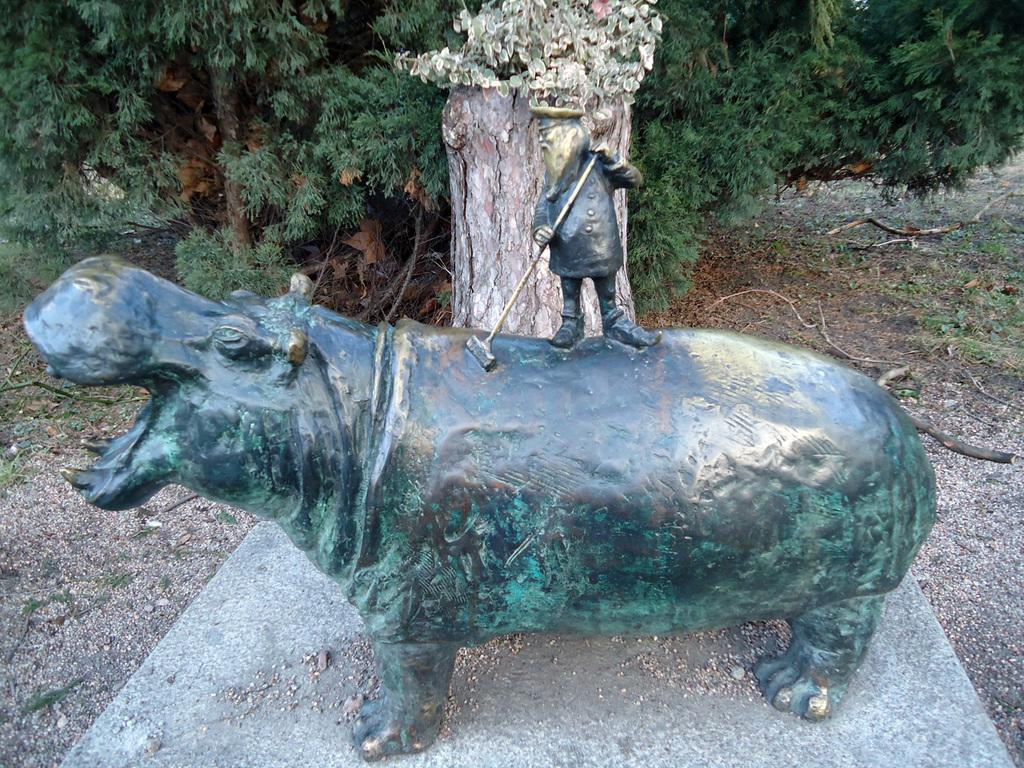What is the main subject in the center of the image? There is a statue in the center of the image. What can be seen in the background of the image? There are trees in the background of the image. How many thumbs are visible on the statue in the image? There are no thumbs visible on the statue in the image, as it is a statue and not a living being. 